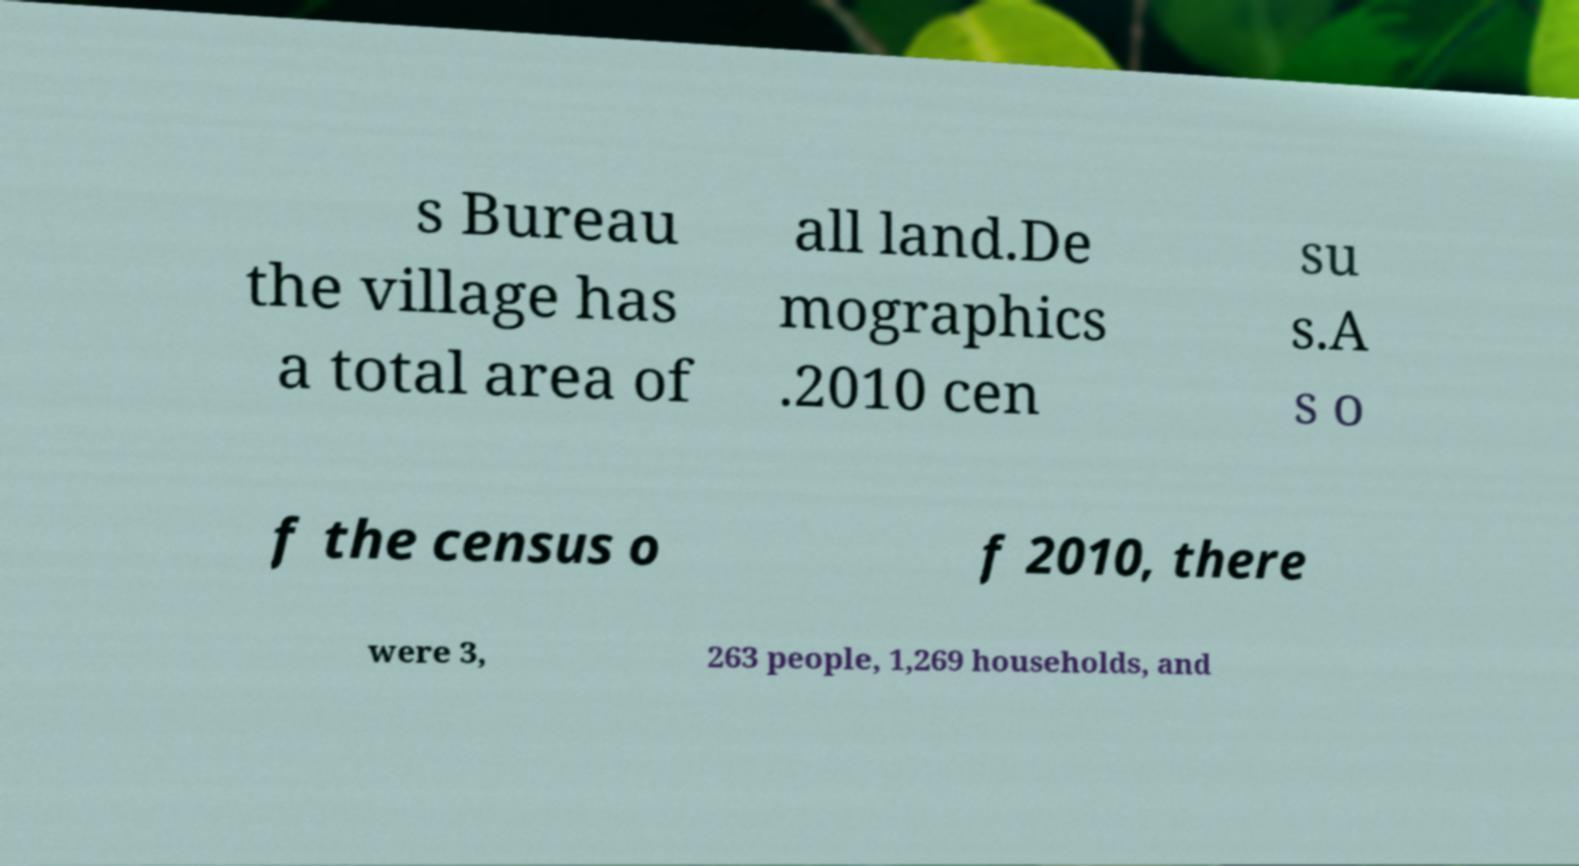Can you accurately transcribe the text from the provided image for me? s Bureau the village has a total area of all land.De mographics .2010 cen su s.A s o f the census o f 2010, there were 3, 263 people, 1,269 households, and 